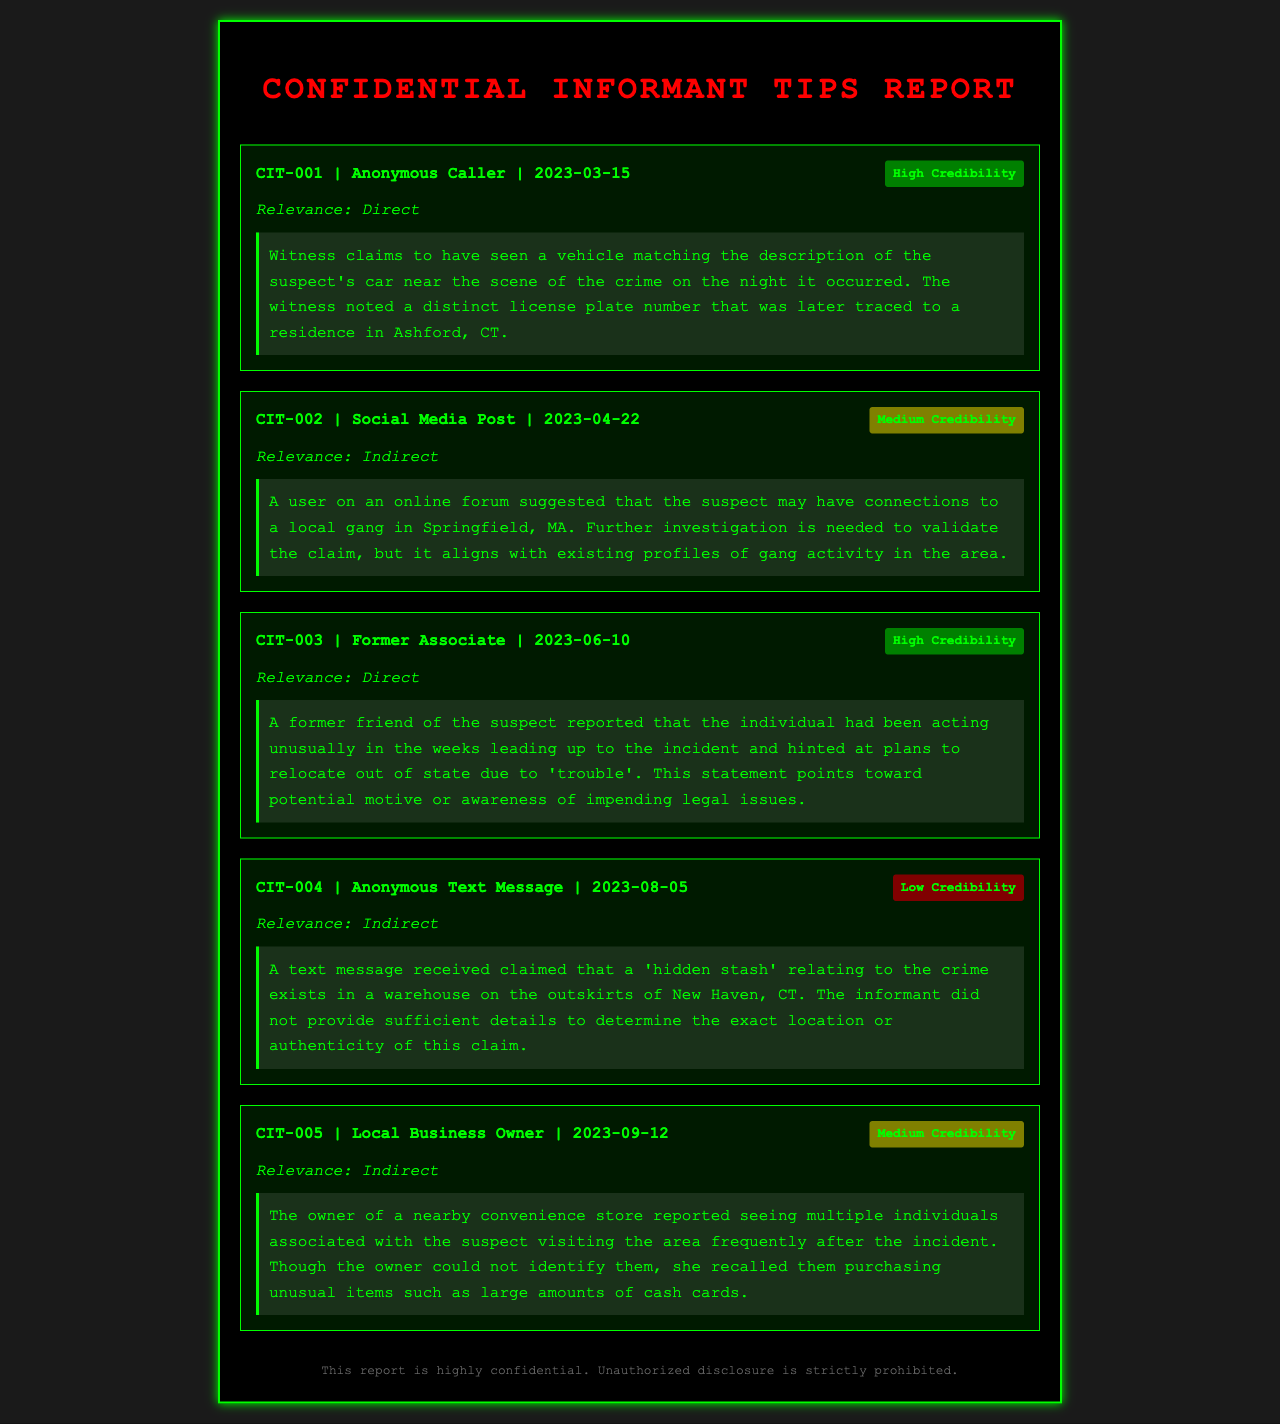what is the date of the first tip? The first tip was submitted on March 15, 2023.
Answer: March 15, 2023 who provided the third tip? The third tip was provided by a former associate of the suspect.
Answer: Former Associate how many tips have high credibility? There are two tips categorized with high credibility.
Answer: 2 what is the relevance of CIT-004? The relevance of CIT-004 is categorized as indirect.
Answer: Indirect what claim did the anonymous caller report in CIT-001? The anonymous caller reported seeing a vehicle matching the suspect's car.
Answer: Vehicle matching the suspect's car what is the credibility level of the tip from the local business owner? The credibility level of the tip from the local business owner is medium.
Answer: Medium what item did the convenience store owner notice being purchased? The convenience store owner noticed large amounts of cash cards being purchased.
Answer: Large amounts of cash cards how many tips suggest direct relevance? There are three tips that suggest direct relevance.
Answer: 3 what was the tip given on April 22 about? The tip on April 22 involved a suggestion of gang connections to the suspect.
Answer: Suggestion of gang connections to the suspect 